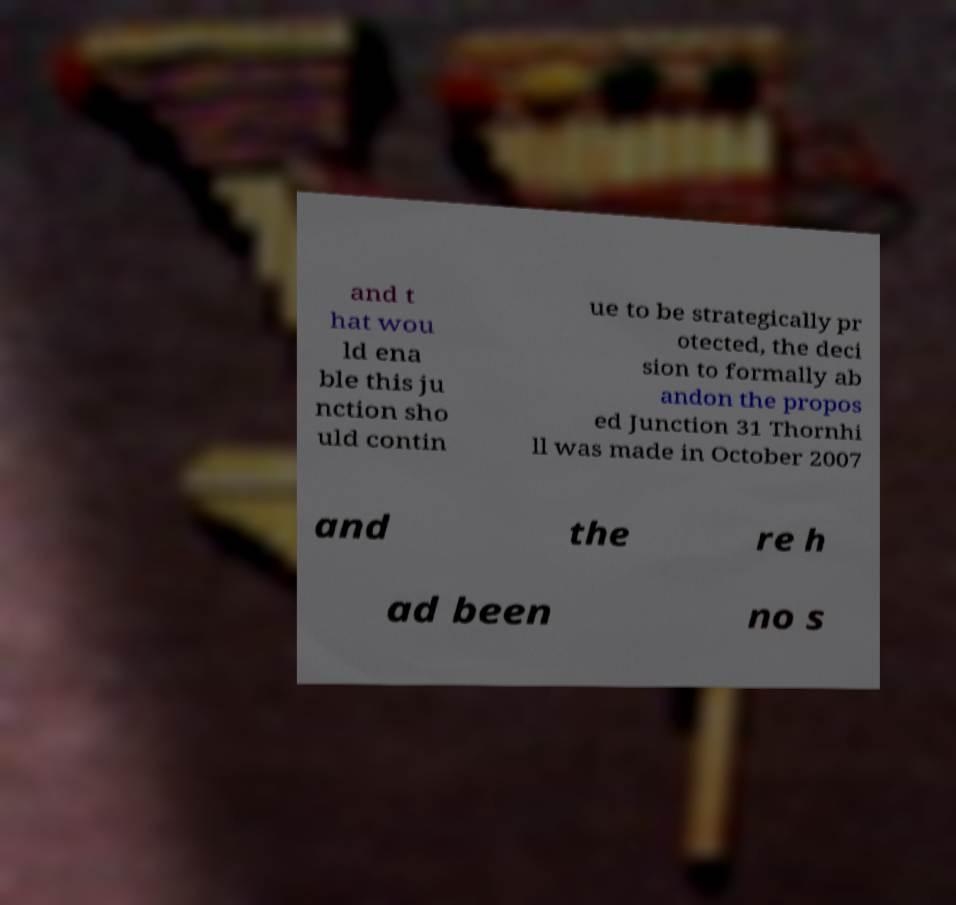There's text embedded in this image that I need extracted. Can you transcribe it verbatim? and t hat wou ld ena ble this ju nction sho uld contin ue to be strategically pr otected, the deci sion to formally ab andon the propos ed Junction 31 Thornhi ll was made in October 2007 and the re h ad been no s 